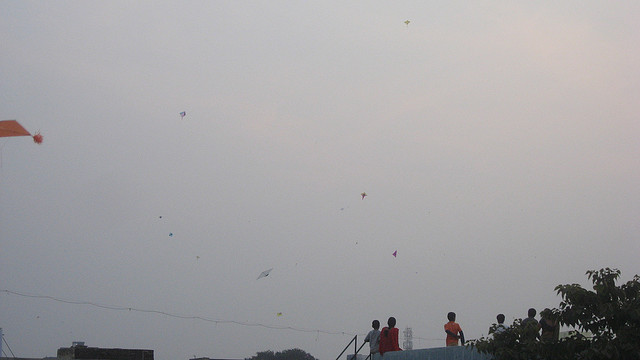<image>What flag is waving? There is no flag waving in the image. What flag is waving? I don't know what flag is waving. It can be seen orange, red, kite or no flag. 